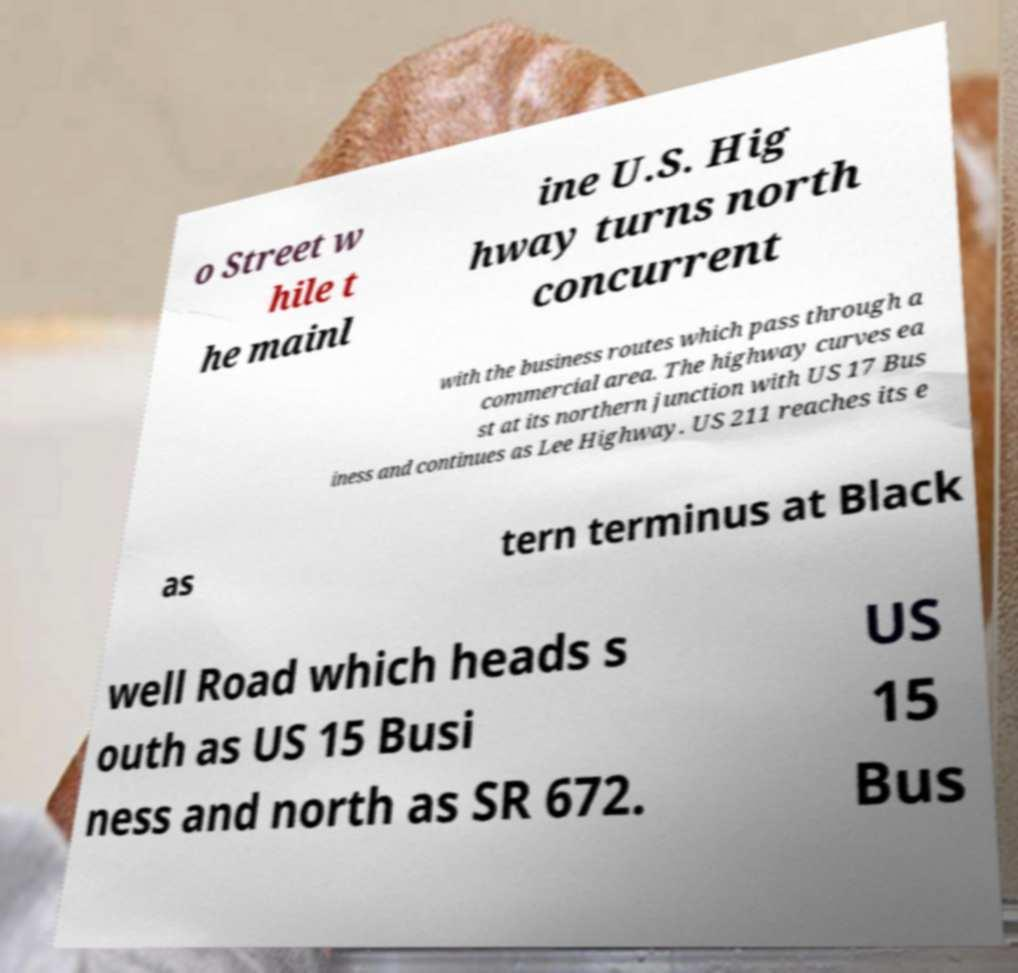Could you assist in decoding the text presented in this image and type it out clearly? o Street w hile t he mainl ine U.S. Hig hway turns north concurrent with the business routes which pass through a commercial area. The highway curves ea st at its northern junction with US 17 Bus iness and continues as Lee Highway. US 211 reaches its e as tern terminus at Black well Road which heads s outh as US 15 Busi ness and north as SR 672. US 15 Bus 